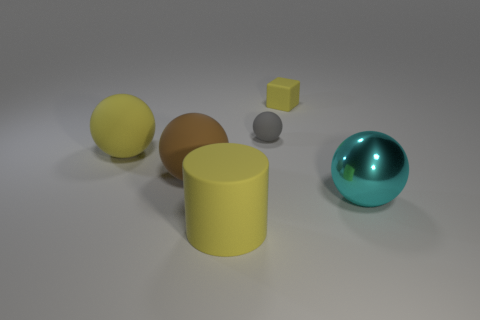Subtract all cyan shiny spheres. How many spheres are left? 3 Add 1 brown matte cylinders. How many objects exist? 7 Subtract all blocks. How many objects are left? 5 Add 1 things. How many things are left? 7 Add 4 big cyan metal objects. How many big cyan metal objects exist? 5 Subtract all cyan balls. How many balls are left? 3 Subtract 0 blue blocks. How many objects are left? 6 Subtract all purple balls. Subtract all red cylinders. How many balls are left? 4 Subtract all small green metallic things. Subtract all big metal things. How many objects are left? 5 